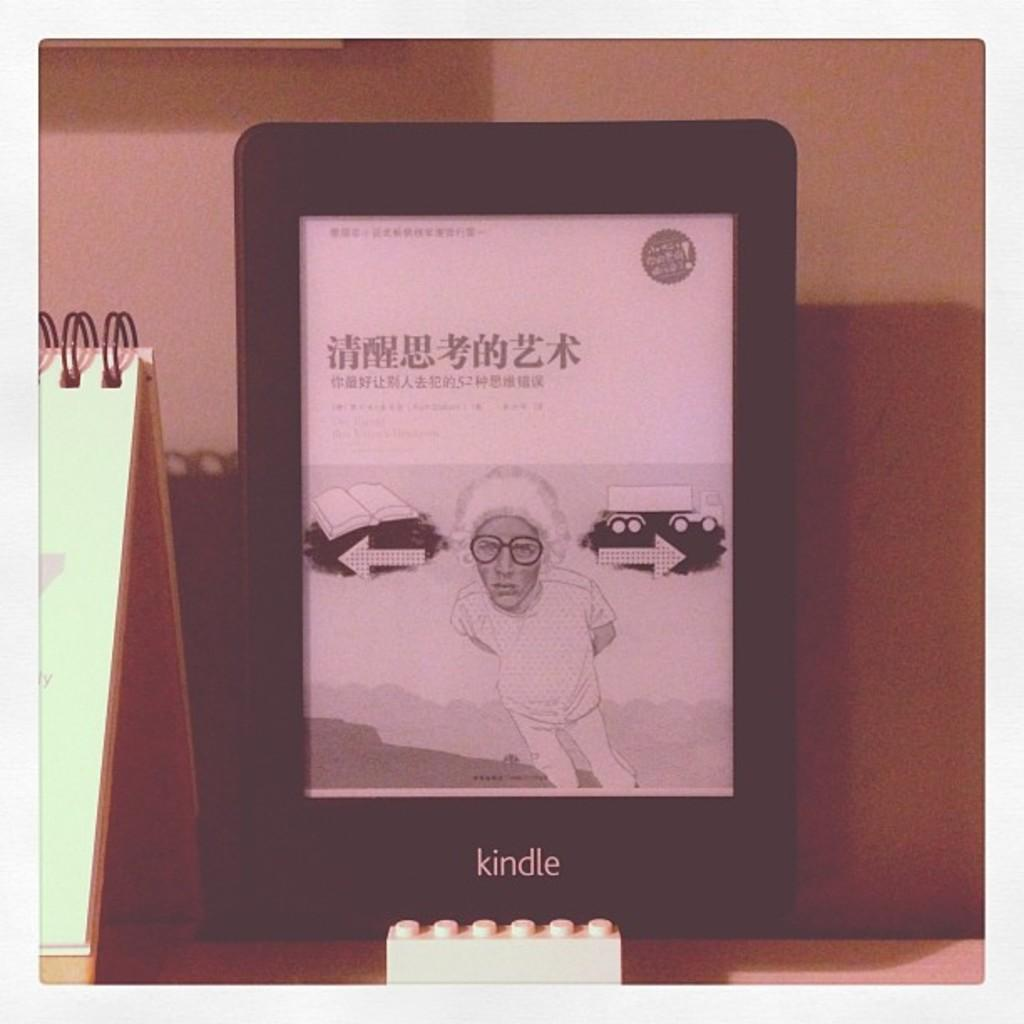What is the main subject of the image? The main subject of the image is a tab. What can be seen on the tab? A person is visible on the tab. What is visible in the background of the image? There is a wall in the background of the image. What type of glove is the person wearing in the image? There is no glove visible in the image; the person on the tab is not wearing any gloves. What grade does the person on the tab represent in the image? There is no indication of a grade or level in the image; it simply features a person on a tab with a wall in the background. 